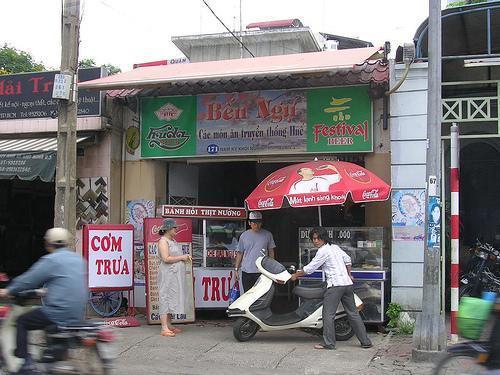How many people are wearing a hat?
Give a very brief answer. 3. 